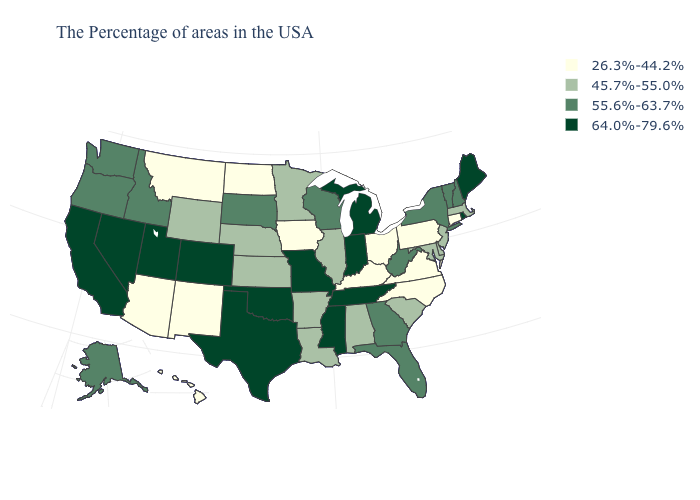What is the value of Oklahoma?
Concise answer only. 64.0%-79.6%. What is the lowest value in the USA?
Be succinct. 26.3%-44.2%. What is the value of Virginia?
Write a very short answer. 26.3%-44.2%. What is the lowest value in states that border Delaware?
Be succinct. 26.3%-44.2%. Which states hav the highest value in the West?
Answer briefly. Colorado, Utah, Nevada, California. What is the lowest value in the USA?
Keep it brief. 26.3%-44.2%. Among the states that border New Mexico , which have the lowest value?
Answer briefly. Arizona. Is the legend a continuous bar?
Give a very brief answer. No. Name the states that have a value in the range 55.6%-63.7%?
Write a very short answer. New Hampshire, Vermont, New York, West Virginia, Florida, Georgia, Wisconsin, South Dakota, Idaho, Washington, Oregon, Alaska. Name the states that have a value in the range 55.6%-63.7%?
Be succinct. New Hampshire, Vermont, New York, West Virginia, Florida, Georgia, Wisconsin, South Dakota, Idaho, Washington, Oregon, Alaska. Is the legend a continuous bar?
Be succinct. No. What is the value of Rhode Island?
Short answer required. 64.0%-79.6%. What is the value of North Dakota?
Be succinct. 26.3%-44.2%. Name the states that have a value in the range 64.0%-79.6%?
Give a very brief answer. Maine, Rhode Island, Michigan, Indiana, Tennessee, Mississippi, Missouri, Oklahoma, Texas, Colorado, Utah, Nevada, California. 